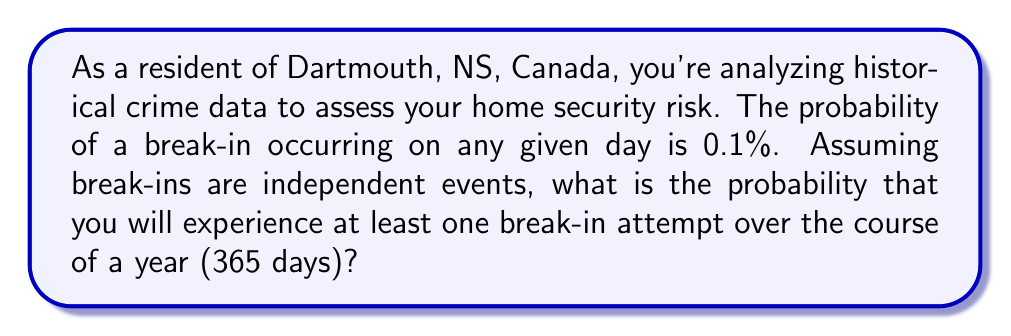Can you solve this math problem? To solve this problem, we'll use the concept of probability for independent events and the complement rule.

1. Let's define our events:
   $P(B)$ = Probability of a break-in on a single day = 0.001 (0.1%)
   $P(N)$ = Probability of no break-in on a single day = 1 - 0.001 = 0.999 (99.9%)

2. We want to find the probability of at least one break-in in 365 days. It's easier to calculate the probability of no break-ins in 365 days and then subtract from 1.

3. The probability of no break-ins in 365 days:
   $P(\text{No break-ins in 365 days}) = P(N)^{365} = 0.999^{365}$

4. Now, we can use the complement rule to find the probability of at least one break-in:
   $P(\text{At least one break-in}) = 1 - P(\text{No break-ins in 365 days})$
   $= 1 - 0.999^{365}$

5. Let's calculate this:
   $1 - 0.999^{365} \approx 1 - 0.6946 = 0.3054$

6. Convert to a percentage:
   $0.3054 \times 100\% = 30.54\%$

Therefore, the probability of experiencing at least one break-in attempt over the course of a year is approximately 30.54%.
Answer: The probability of experiencing at least one break-in attempt over the course of a year (365 days) is approximately $30.54\%$. 